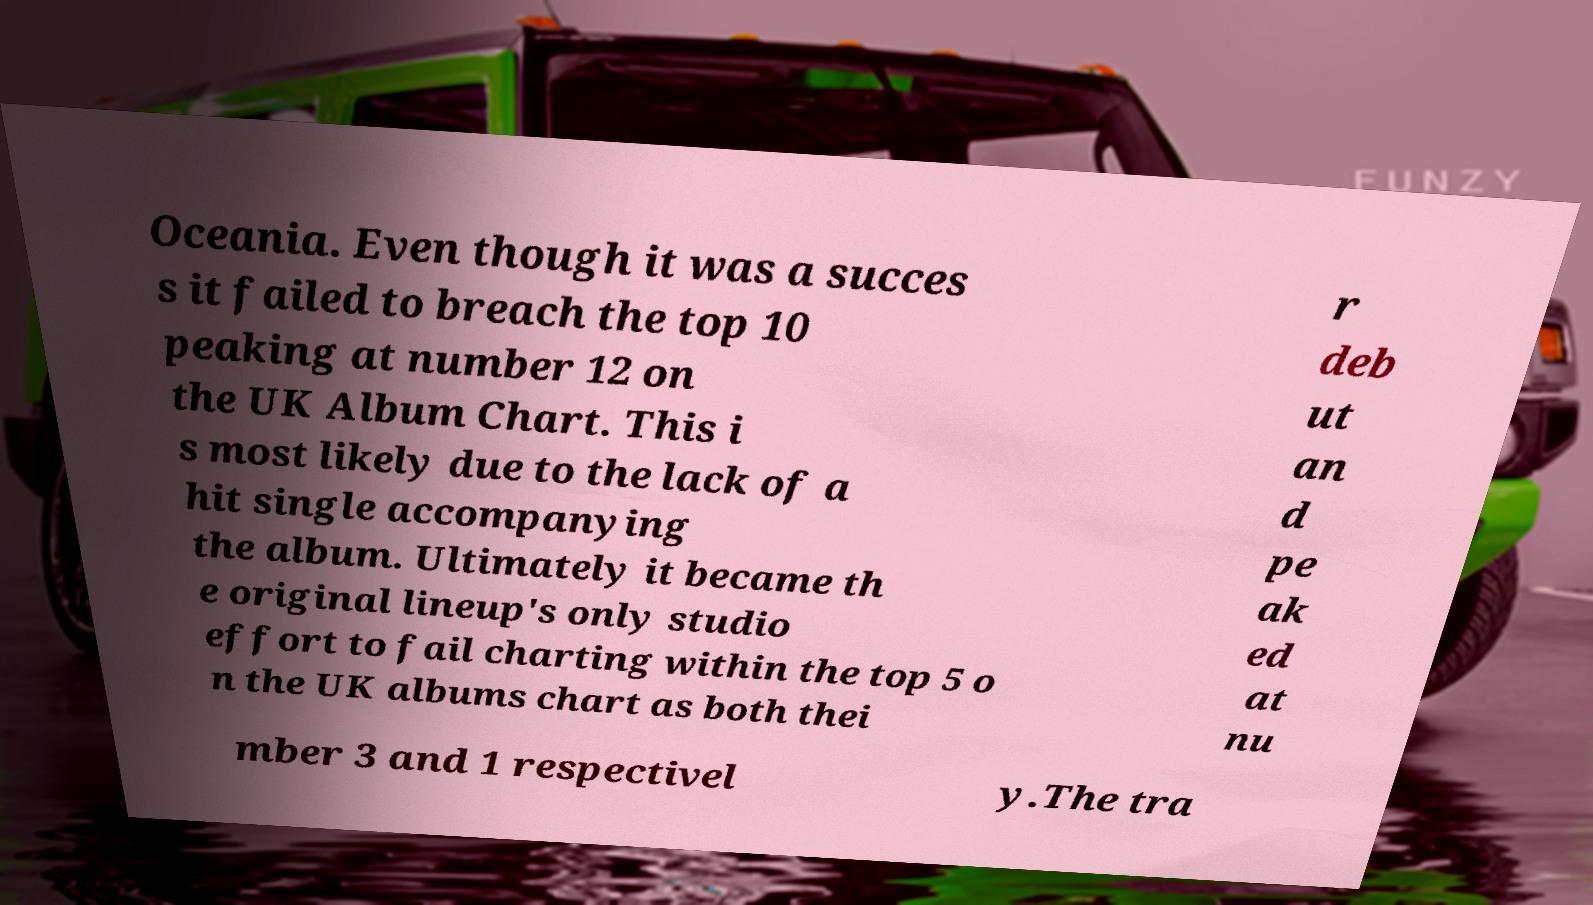Can you read and provide the text displayed in the image?This photo seems to have some interesting text. Can you extract and type it out for me? Oceania. Even though it was a succes s it failed to breach the top 10 peaking at number 12 on the UK Album Chart. This i s most likely due to the lack of a hit single accompanying the album. Ultimately it became th e original lineup's only studio effort to fail charting within the top 5 o n the UK albums chart as both thei r deb ut an d pe ak ed at nu mber 3 and 1 respectivel y.The tra 